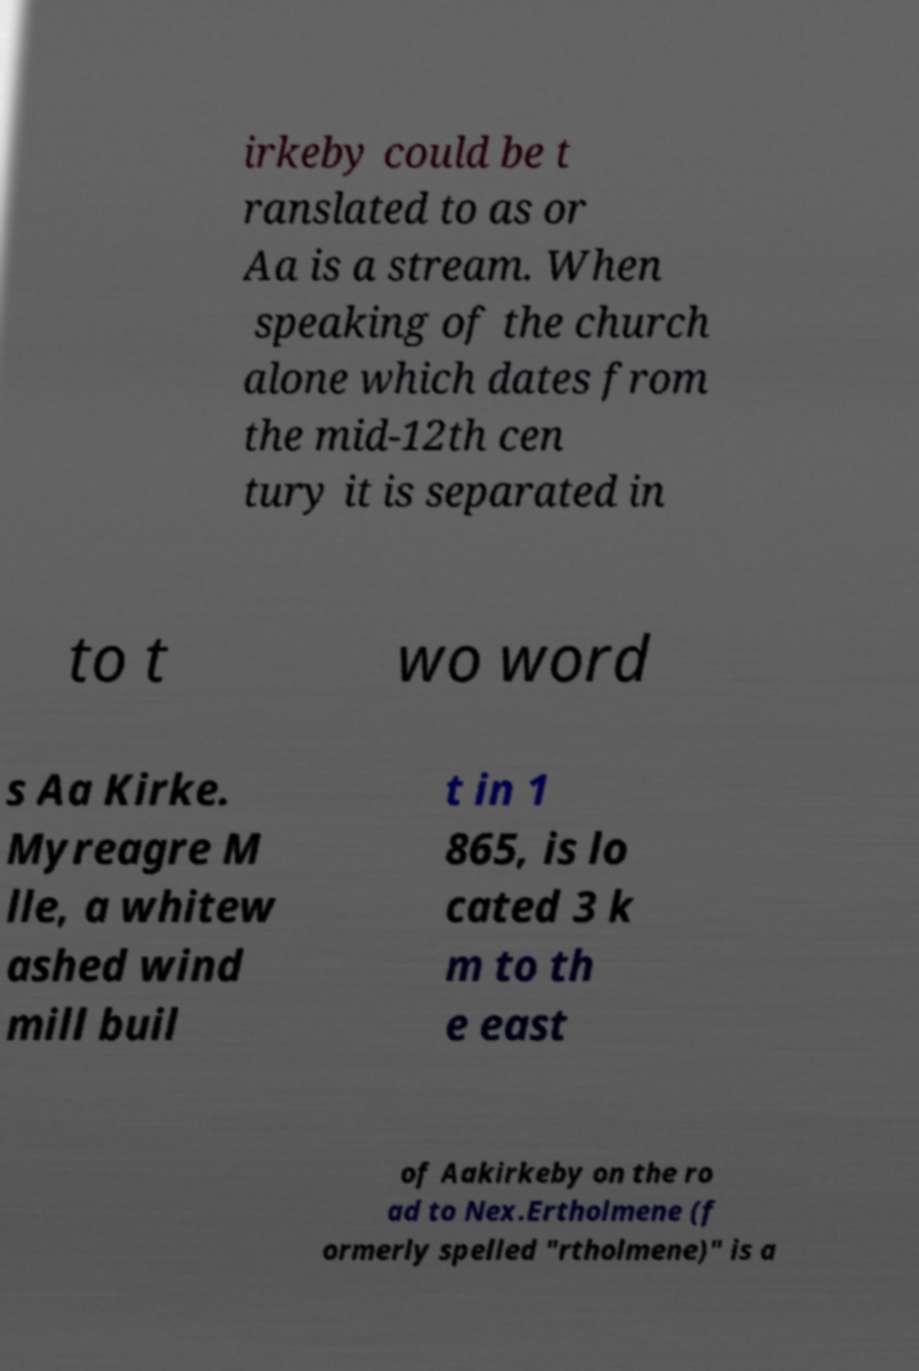I need the written content from this picture converted into text. Can you do that? irkeby could be t ranslated to as or Aa is a stream. When speaking of the church alone which dates from the mid-12th cen tury it is separated in to t wo word s Aa Kirke. Myreagre M lle, a whitew ashed wind mill buil t in 1 865, is lo cated 3 k m to th e east of Aakirkeby on the ro ad to Nex.Ertholmene (f ormerly spelled "rtholmene)" is a 